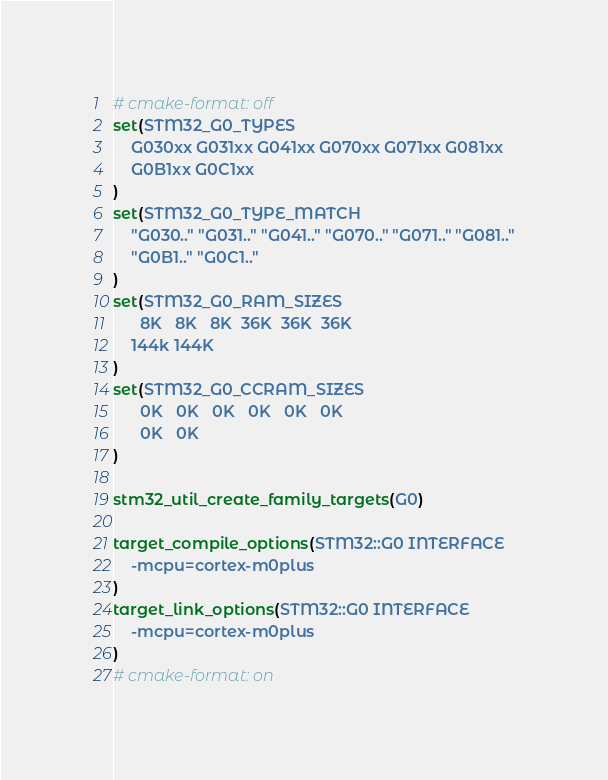Convert code to text. <code><loc_0><loc_0><loc_500><loc_500><_CMake_># cmake-format: off
set(STM32_G0_TYPES 
    G030xx G031xx G041xx G070xx G071xx G081xx
    G0B1xx G0C1xx
)
set(STM32_G0_TYPE_MATCH 
    "G030.." "G031.." "G041.." "G070.." "G071.." "G081.."
    "G0B1.." "G0C1.."
)
set(STM32_G0_RAM_SIZES 
      8K   8K   8K  36K  36K  36K
    144k 144K
)
set(STM32_G0_CCRAM_SIZES 
      0K   0K   0K   0K   0K   0K
      0K   0K
)

stm32_util_create_family_targets(G0)

target_compile_options(STM32::G0 INTERFACE 
    -mcpu=cortex-m0plus
)
target_link_options(STM32::G0 INTERFACE 
    -mcpu=cortex-m0plus
)
# cmake-format: on
</code> 